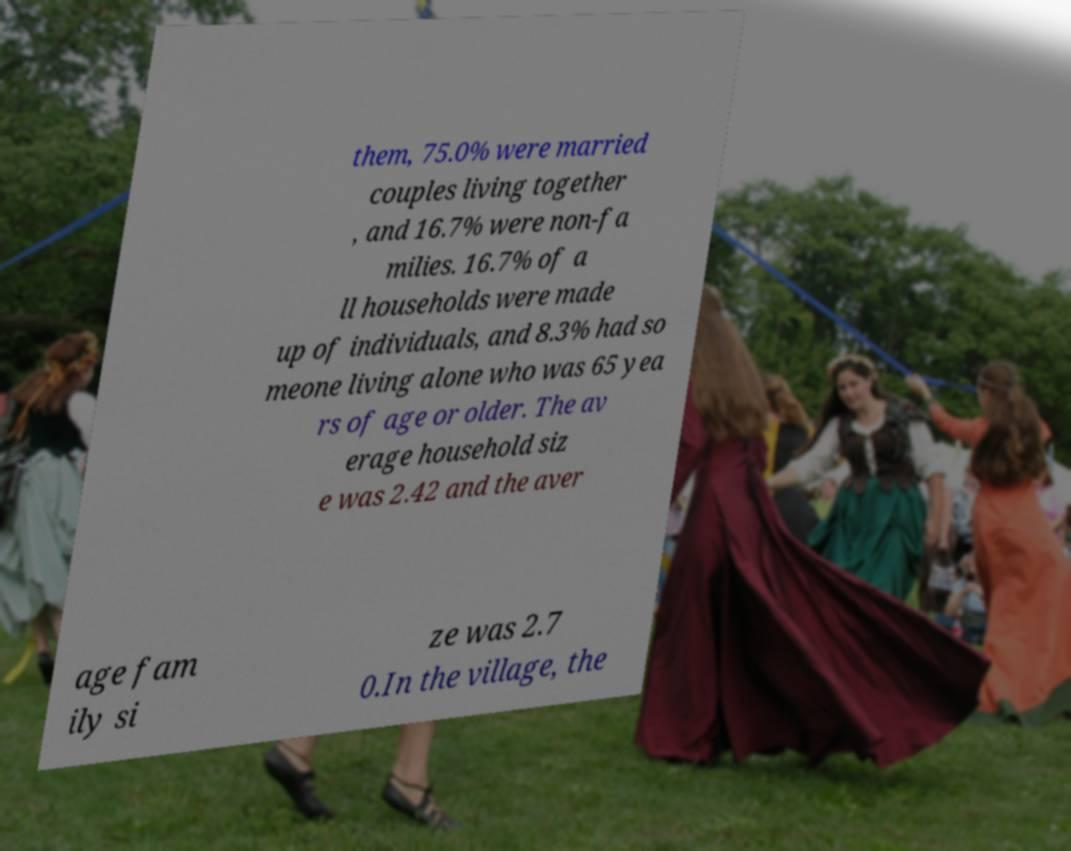Please identify and transcribe the text found in this image. them, 75.0% were married couples living together , and 16.7% were non-fa milies. 16.7% of a ll households were made up of individuals, and 8.3% had so meone living alone who was 65 yea rs of age or older. The av erage household siz e was 2.42 and the aver age fam ily si ze was 2.7 0.In the village, the 